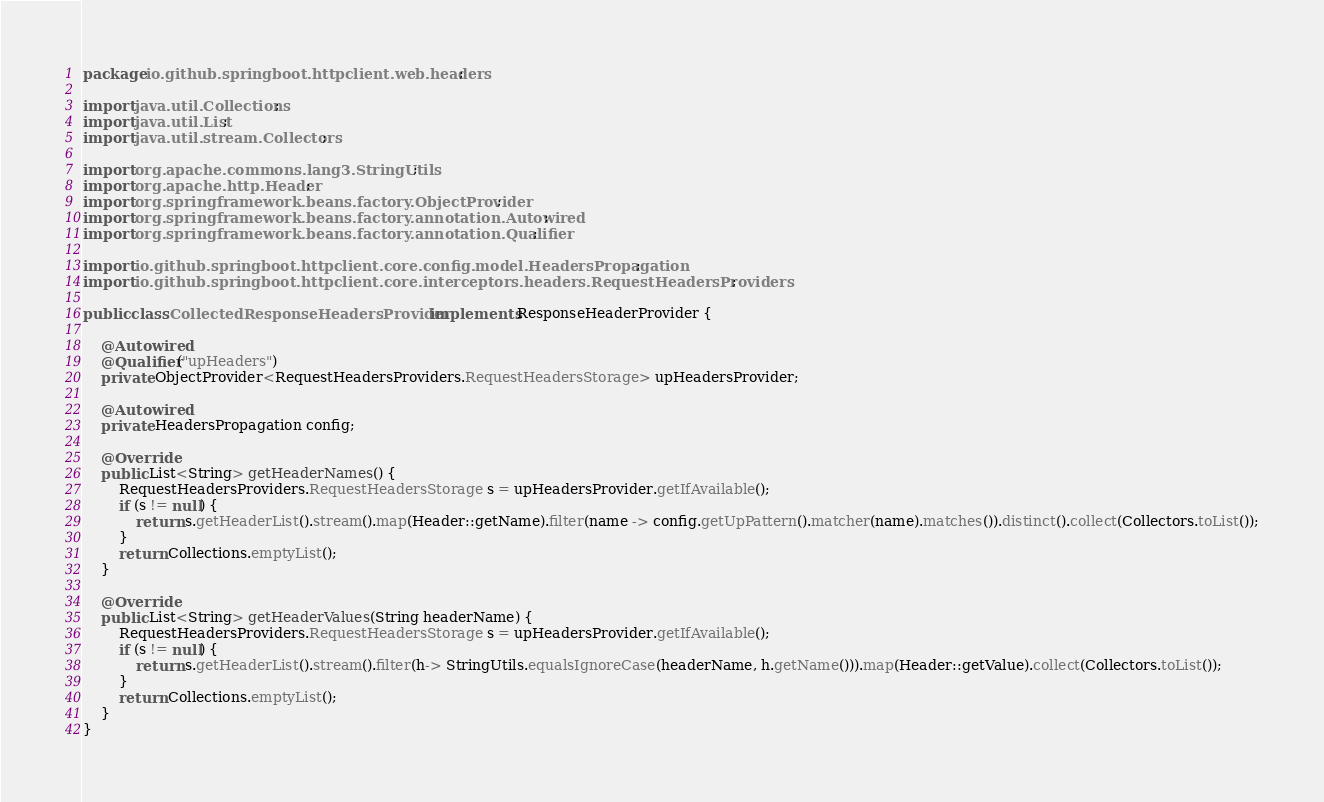<code> <loc_0><loc_0><loc_500><loc_500><_Java_>package io.github.springboot.httpclient.web.headers;

import java.util.Collections;
import java.util.List;
import java.util.stream.Collectors;

import org.apache.commons.lang3.StringUtils;
import org.apache.http.Header;
import org.springframework.beans.factory.ObjectProvider;
import org.springframework.beans.factory.annotation.Autowired;
import org.springframework.beans.factory.annotation.Qualifier;

import io.github.springboot.httpclient.core.config.model.HeadersPropagation;
import io.github.springboot.httpclient.core.interceptors.headers.RequestHeadersProviders;

public class CollectedResponseHeadersProvider implements ResponseHeaderProvider {

    @Autowired
    @Qualifier("upHeaders")
    private ObjectProvider<RequestHeadersProviders.RequestHeadersStorage> upHeadersProvider;

    @Autowired
    private HeadersPropagation config;

    @Override
    public List<String> getHeaderNames() {
        RequestHeadersProviders.RequestHeadersStorage s = upHeadersProvider.getIfAvailable();
        if (s != null) {
            return s.getHeaderList().stream().map(Header::getName).filter(name -> config.getUpPattern().matcher(name).matches()).distinct().collect(Collectors.toList());
        }
        return Collections.emptyList();
    }

    @Override
    public List<String> getHeaderValues(String headerName) {
        RequestHeadersProviders.RequestHeadersStorage s = upHeadersProvider.getIfAvailable();
        if (s != null) {
            return s.getHeaderList().stream().filter(h-> StringUtils.equalsIgnoreCase(headerName, h.getName())).map(Header::getValue).collect(Collectors.toList());
        }
        return Collections.emptyList();
    }
}
</code> 